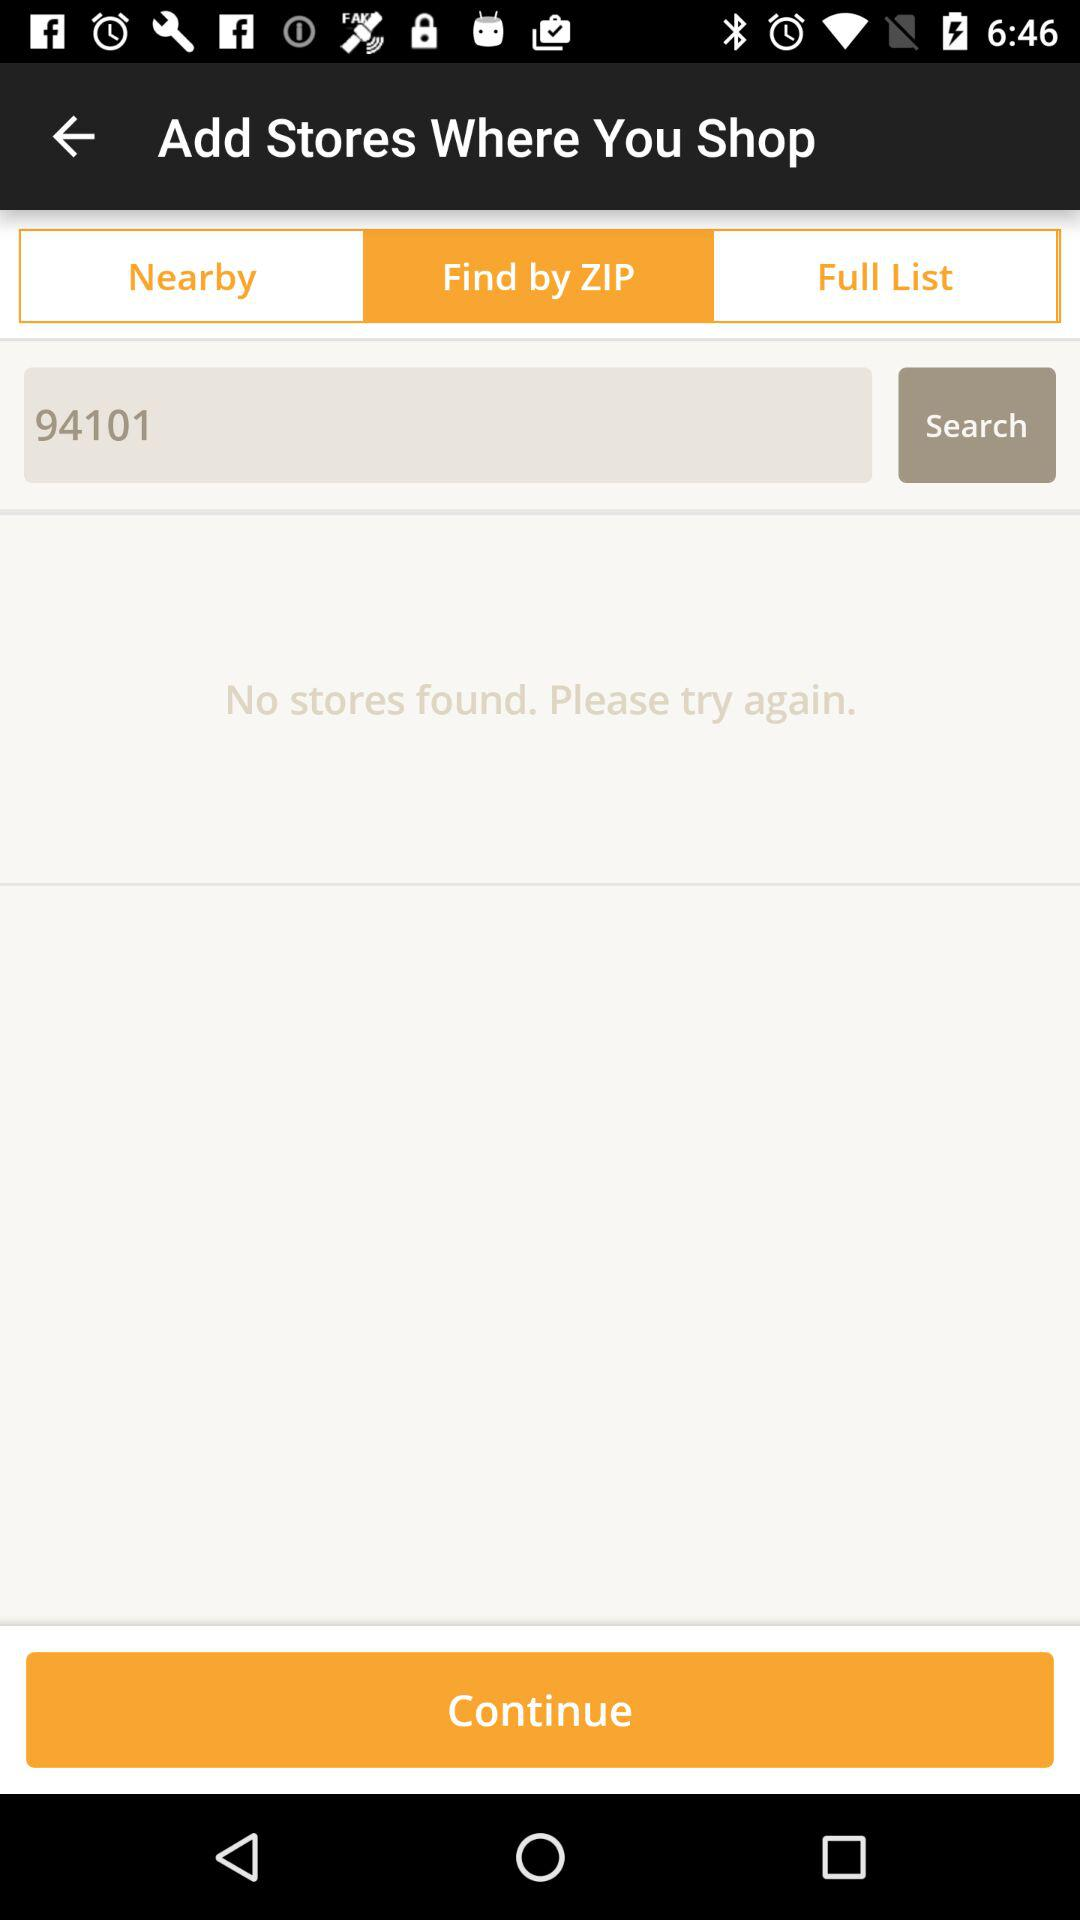Were any stores found? There were no stores found. 